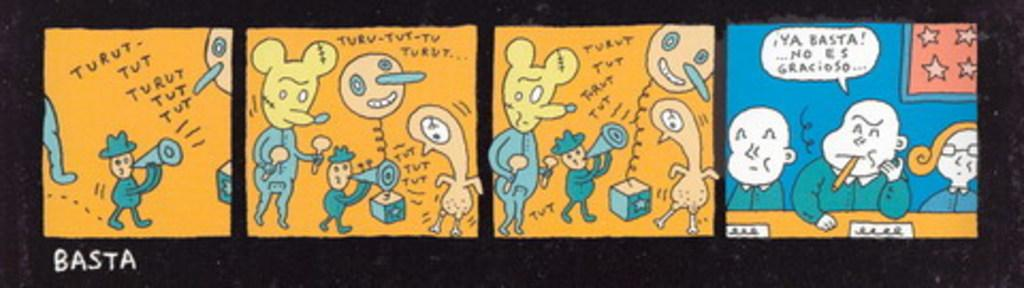<image>
Provide a brief description of the given image. The Sunday cartoon strip is in Spanish and is very comical. 